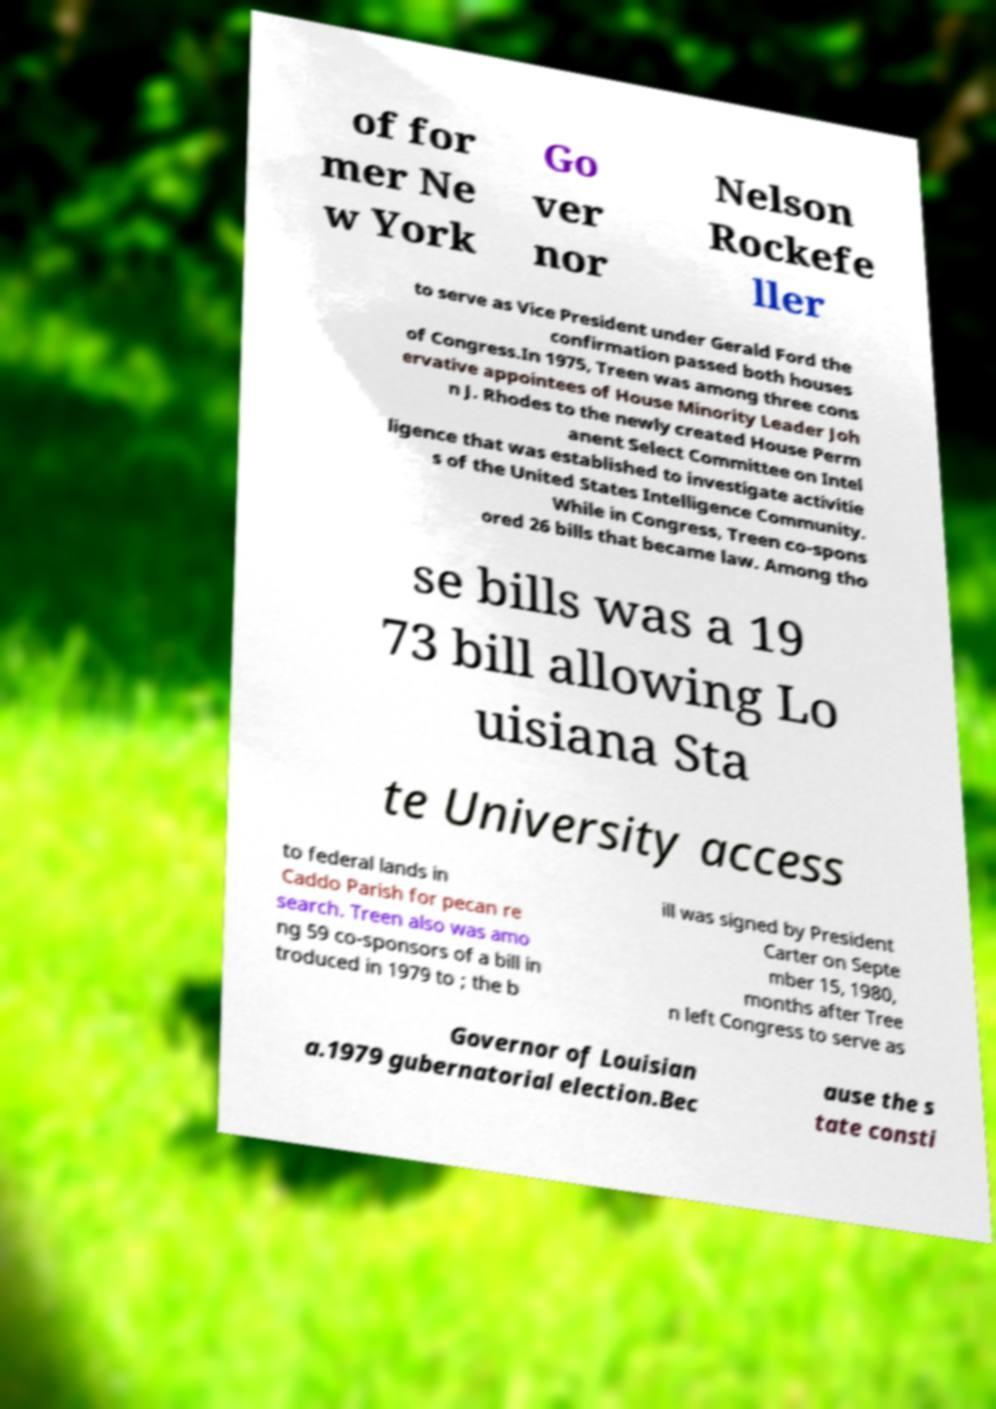Could you assist in decoding the text presented in this image and type it out clearly? of for mer Ne w York Go ver nor Nelson Rockefe ller to serve as Vice President under Gerald Ford the confirmation passed both houses of Congress.In 1975, Treen was among three cons ervative appointees of House Minority Leader Joh n J. Rhodes to the newly created House Perm anent Select Committee on Intel ligence that was established to investigate activitie s of the United States Intelligence Community. While in Congress, Treen co-spons ored 26 bills that became law. Among tho se bills was a 19 73 bill allowing Lo uisiana Sta te University access to federal lands in Caddo Parish for pecan re search. Treen also was amo ng 59 co-sponsors of a bill in troduced in 1979 to ; the b ill was signed by President Carter on Septe mber 15, 1980, months after Tree n left Congress to serve as Governor of Louisian a.1979 gubernatorial election.Bec ause the s tate consti 